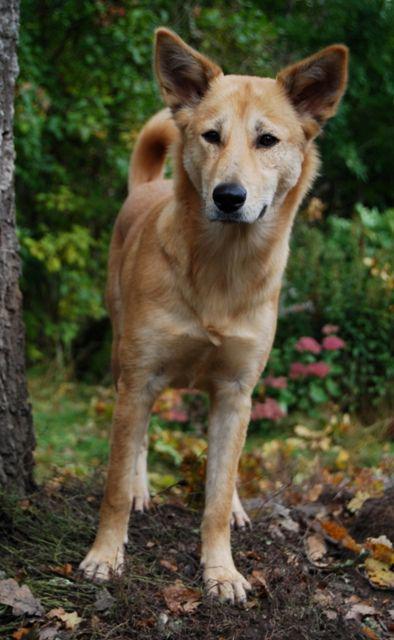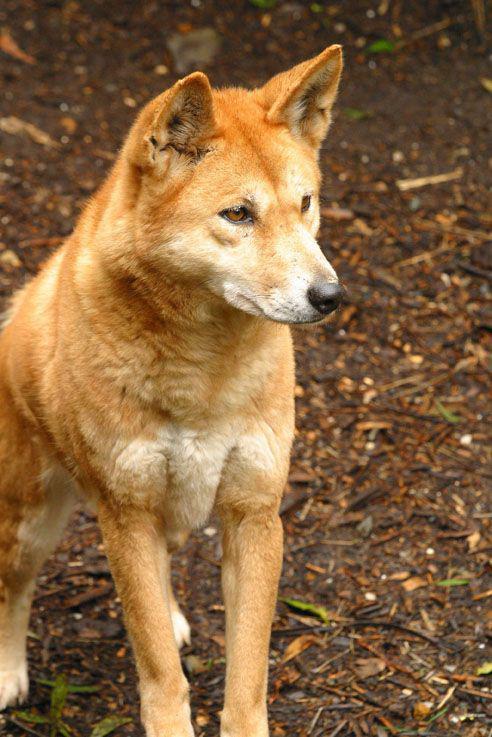The first image is the image on the left, the second image is the image on the right. For the images displayed, is the sentence "There are two animals in the image on the right." factually correct? Answer yes or no. No. 